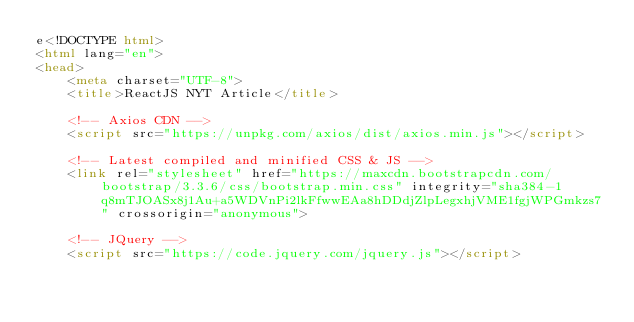Convert code to text. <code><loc_0><loc_0><loc_500><loc_500><_HTML_>e<!DOCTYPE html>
<html lang="en">
<head>
	<meta charset="UTF-8">
	<title>ReactJS NYT Article</title>

	<!-- Axios CDN -->
	<script src="https://unpkg.com/axios/dist/axios.min.js"></script>
	
	<!-- Latest compiled and minified CSS & JS -->
	<link rel="stylesheet" href="https://maxcdn.bootstrapcdn.com/bootstrap/3.3.6/css/bootstrap.min.css" integrity="sha384-1q8mTJOASx8j1Au+a5WDVnPi2lkFfwwEAa8hDDdjZlpLegxhjVME1fgjWPGmkzs7" crossorigin="anonymous">
	
	<!-- JQuery -->
	<script src="https://code.jquery.com/jquery.js"></script>
	</code> 